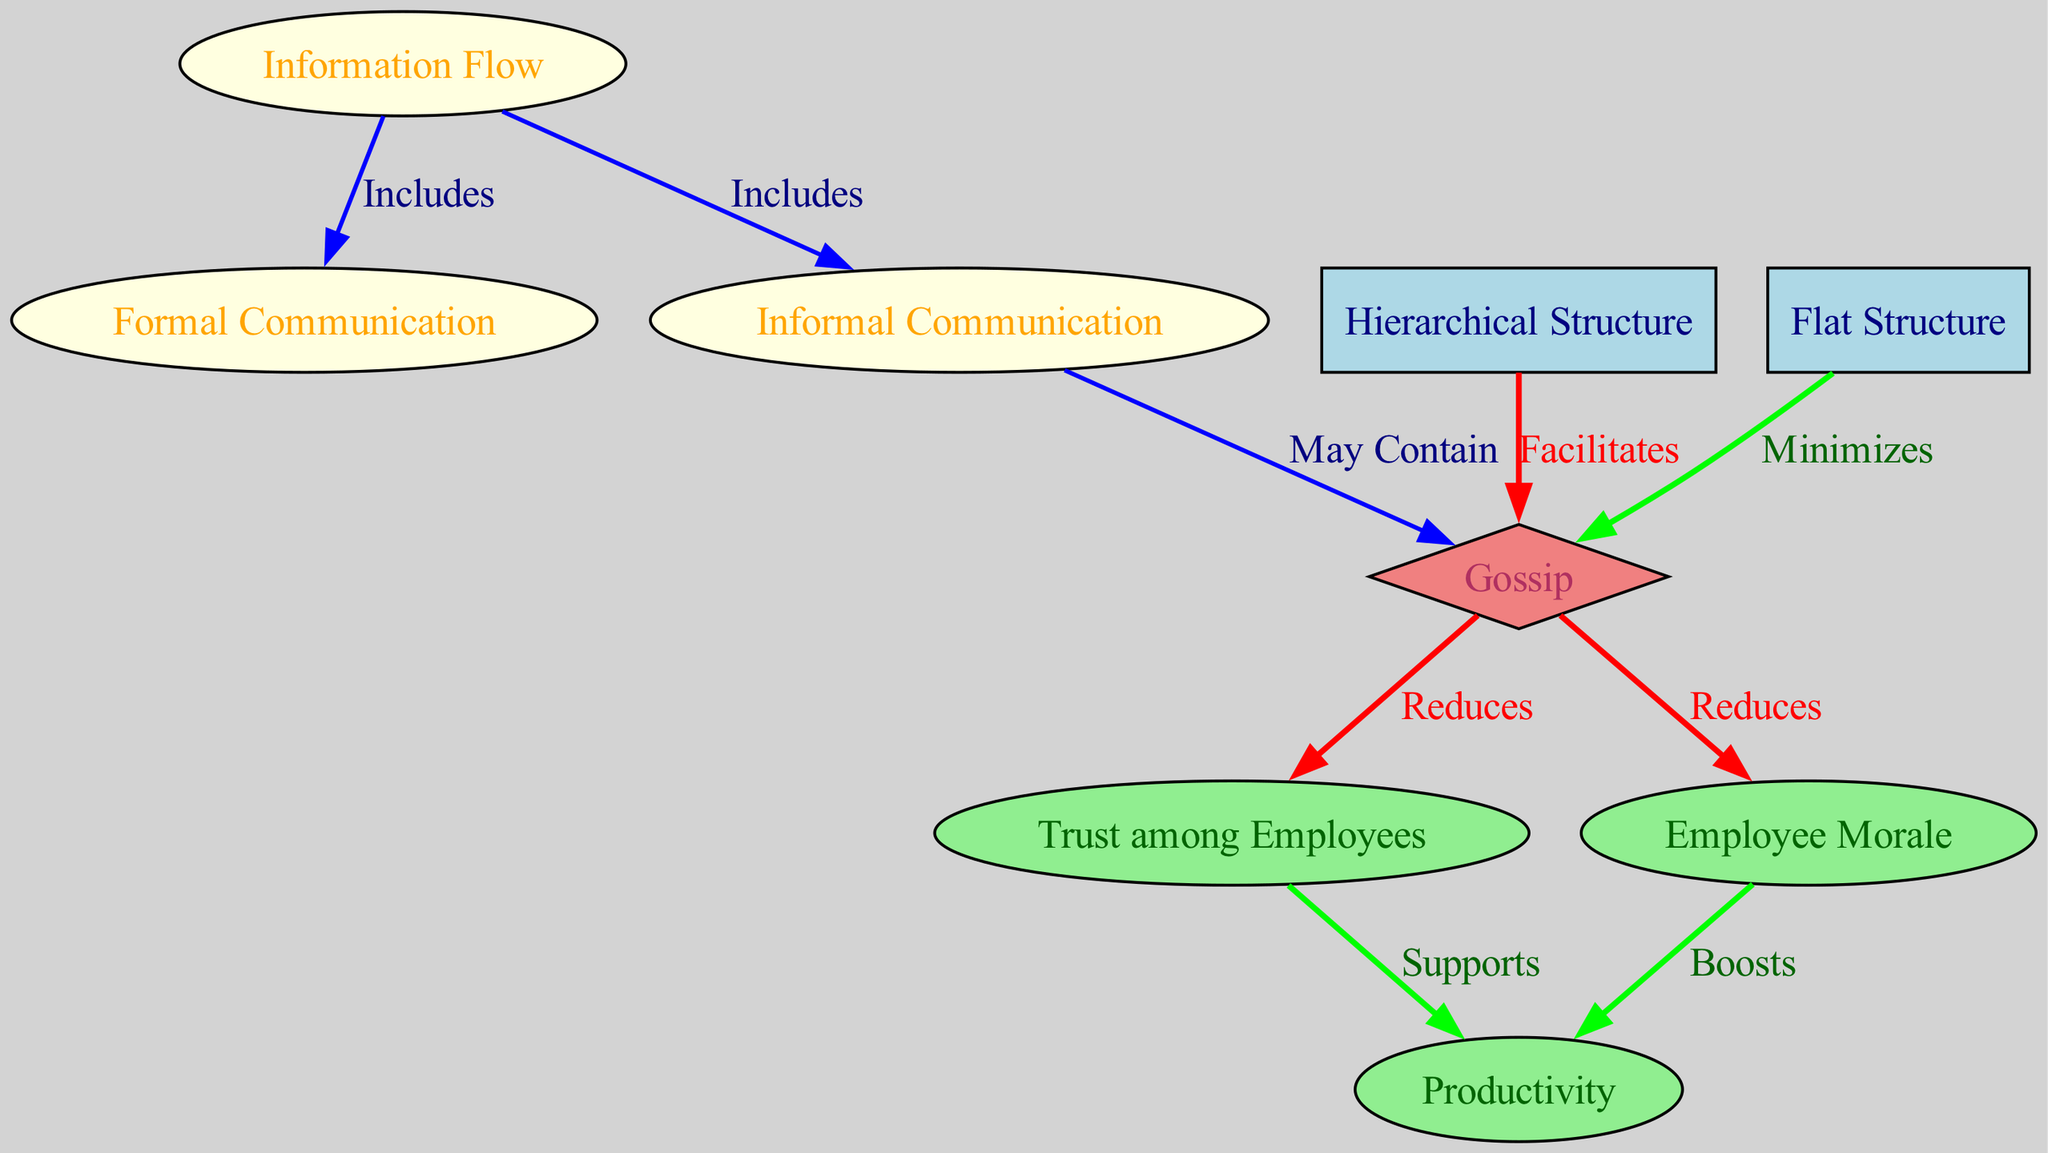What is the total number of nodes in the diagram? The diagram includes a count of all distinct nodes. By counting the "nodes" section in the provided data, we see there are 8 unique entries.
Answer: 8 Which type of structure facilitates gossip? Upon examining the connections, the edge that shows "Facilitates" connects "Hierarchical Structure" to "Gossip". Thus, it's clear that hierarchical structures promote gossip.
Answer: Hierarchical Structure What does gossip reduce among employees? The diagram indicates two connections leading out from "Gossip," both labeled as "Reduces." These connections lead to "Trust among Employees" and "Employee Morale," indicating that gossip negatively impacts both areas.
Answer: Trust, Morale What is the relationship between trust and productivity? The relationship shown in the diagram demonstrates that "Trust" directly "Supports" "Productivity." This indicates that higher trust levels lead to increased productivity in the workplace.
Answer: Supports Which structure minimizes gossip? The link labeled "Minimizes" connects "Flat Structure" directly to "Gossip," denoting that flatter organizational structures help reduce gossip among employees.
Answer: Flat Structure How many edges are labeled "Reduces"? The edges information reveals that there are two specific edges connected to "Gossip" that are marked as "Reduces". These edges each lead to "Trust" and "Morale".
Answer: 2 What does employee morale boost according to the diagram? The connection between "Morale" and "Productivity" labeled as "Boosts" indicates that employee morale positively impacts productivity levels, fostering a more efficient workplace.
Answer: Productivity Which type of communication may contain gossip? The diagram shows an edge from "Informal Communication" to "Gossip," suggesting that informal communication is where gossip might arise or be shared among employees.
Answer: Informal Communication 